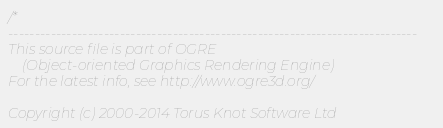<code> <loc_0><loc_0><loc_500><loc_500><_C_>/*
-----------------------------------------------------------------------------
This source file is part of OGRE
    (Object-oriented Graphics Rendering Engine)
For the latest info, see http://www.ogre3d.org/

Copyright (c) 2000-2014 Torus Knot Software Ltd
</code> 